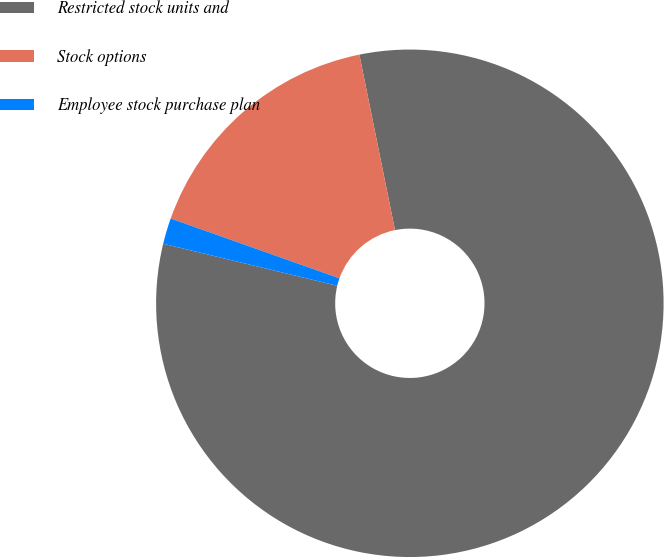Convert chart. <chart><loc_0><loc_0><loc_500><loc_500><pie_chart><fcel>Restricted stock units and<fcel>Stock options<fcel>Employee stock purchase plan<nl><fcel>81.96%<fcel>16.39%<fcel>1.65%<nl></chart> 